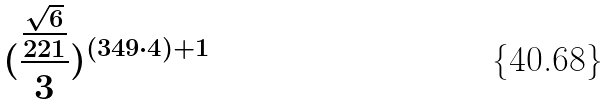Convert formula to latex. <formula><loc_0><loc_0><loc_500><loc_500>( \frac { \frac { \sqrt { 6 } } { 2 2 1 } } { 3 } ) ^ { ( 3 4 9 \cdot 4 ) + 1 }</formula> 